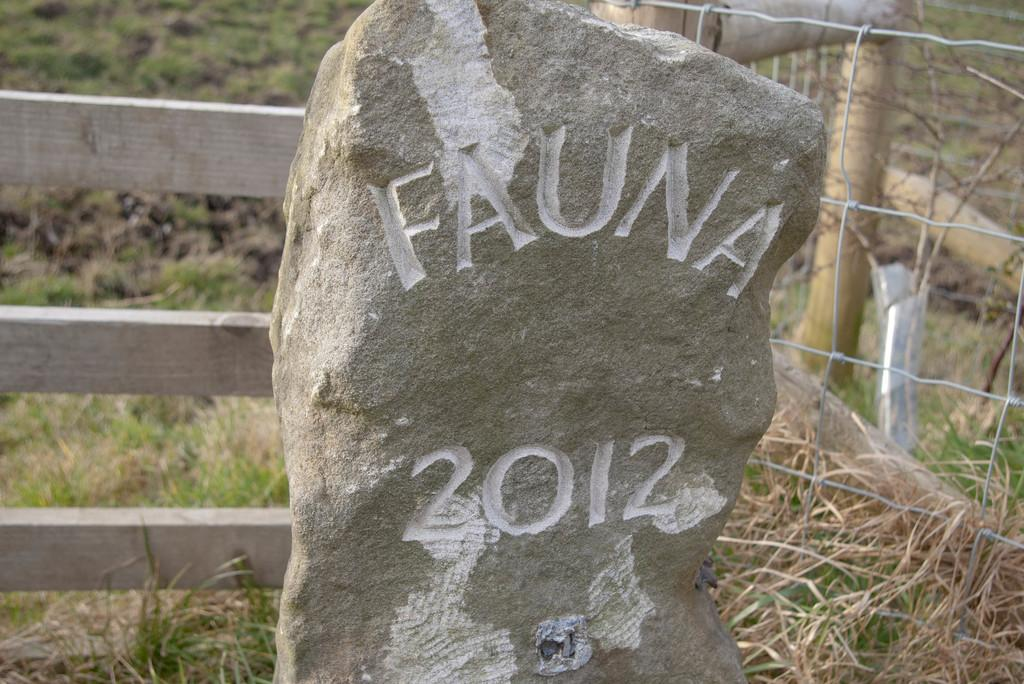What is carved on the rock in the image? There are words and numbers carved on a rock in the image. What is located behind the rock? There is a wooden fence behind the rock. What type of vegetation can be seen in the image? Grass is visible in the image. What might the wooden fence be used for? The wooden fence appears to be a garden fence. What type of toy can be seen in the image? There is no toy present in the image. What does the mom in the image say to the child? There is no mom or child present in the image. 